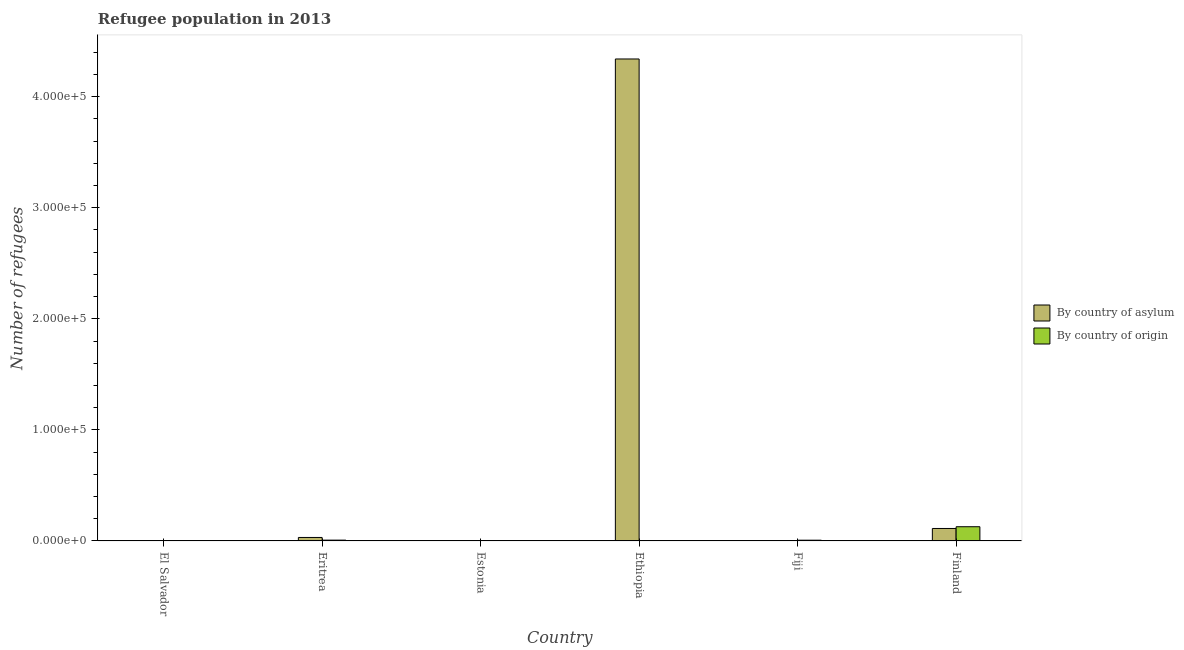How many groups of bars are there?
Provide a short and direct response. 6. Are the number of bars per tick equal to the number of legend labels?
Your answer should be compact. Yes. How many bars are there on the 3rd tick from the left?
Your response must be concise. 2. How many bars are there on the 5th tick from the right?
Your answer should be very brief. 2. What is the label of the 4th group of bars from the left?
Keep it short and to the point. Ethiopia. In how many cases, is the number of bars for a given country not equal to the number of legend labels?
Make the answer very short. 0. What is the number of refugees by country of asylum in Eritrea?
Offer a very short reply. 3166. Across all countries, what is the maximum number of refugees by country of origin?
Your answer should be very brief. 1.28e+04. Across all countries, what is the minimum number of refugees by country of asylum?
Provide a succinct answer. 5. In which country was the number of refugees by country of origin maximum?
Provide a short and direct response. Finland. In which country was the number of refugees by country of asylum minimum?
Ensure brevity in your answer.  Fiji. What is the total number of refugees by country of asylum in the graph?
Make the answer very short. 4.48e+05. What is the difference between the number of refugees by country of origin in Eritrea and that in Fiji?
Ensure brevity in your answer.  55. What is the difference between the number of refugees by country of asylum in El Salvador and the number of refugees by country of origin in Eritrea?
Provide a succinct answer. -718. What is the average number of refugees by country of origin per country?
Offer a very short reply. 2443.67. What is the difference between the number of refugees by country of asylum and number of refugees by country of origin in Fiji?
Offer a very short reply. -702. In how many countries, is the number of refugees by country of asylum greater than 260000 ?
Ensure brevity in your answer.  1. What is the ratio of the number of refugees by country of origin in El Salvador to that in Finland?
Your answer should be very brief. 0. What is the difference between the highest and the second highest number of refugees by country of origin?
Give a very brief answer. 1.21e+04. What is the difference between the highest and the lowest number of refugees by country of asylum?
Give a very brief answer. 4.34e+05. What does the 2nd bar from the left in Eritrea represents?
Your response must be concise. By country of origin. What does the 2nd bar from the right in Estonia represents?
Your answer should be very brief. By country of asylum. Are all the bars in the graph horizontal?
Keep it short and to the point. No. How many countries are there in the graph?
Provide a succinct answer. 6. What is the difference between two consecutive major ticks on the Y-axis?
Offer a terse response. 1.00e+05. Are the values on the major ticks of Y-axis written in scientific E-notation?
Your response must be concise. Yes. Does the graph contain any zero values?
Provide a short and direct response. No. Where does the legend appear in the graph?
Offer a terse response. Center right. How many legend labels are there?
Provide a succinct answer. 2. How are the legend labels stacked?
Offer a terse response. Vertical. What is the title of the graph?
Offer a very short reply. Refugee population in 2013. What is the label or title of the X-axis?
Provide a succinct answer. Country. What is the label or title of the Y-axis?
Keep it short and to the point. Number of refugees. What is the Number of refugees in By country of asylum in El Salvador?
Your response must be concise. 44. What is the Number of refugees of By country of asylum in Eritrea?
Provide a succinct answer. 3166. What is the Number of refugees of By country of origin in Eritrea?
Your response must be concise. 762. What is the Number of refugees of By country of asylum in Estonia?
Make the answer very short. 70. What is the Number of refugees of By country of asylum in Ethiopia?
Provide a short and direct response. 4.34e+05. What is the Number of refugees of By country of origin in Ethiopia?
Give a very brief answer. 306. What is the Number of refugees in By country of origin in Fiji?
Your answer should be very brief. 707. What is the Number of refugees in By country of asylum in Finland?
Your answer should be very brief. 1.13e+04. What is the Number of refugees in By country of origin in Finland?
Your answer should be compact. 1.28e+04. Across all countries, what is the maximum Number of refugees of By country of asylum?
Your response must be concise. 4.34e+05. Across all countries, what is the maximum Number of refugees in By country of origin?
Offer a terse response. 1.28e+04. Across all countries, what is the minimum Number of refugees in By country of asylum?
Provide a succinct answer. 5. Across all countries, what is the minimum Number of refugees in By country of origin?
Ensure brevity in your answer.  10. What is the total Number of refugees in By country of asylum in the graph?
Give a very brief answer. 4.48e+05. What is the total Number of refugees in By country of origin in the graph?
Give a very brief answer. 1.47e+04. What is the difference between the Number of refugees in By country of asylum in El Salvador and that in Eritrea?
Give a very brief answer. -3122. What is the difference between the Number of refugees of By country of origin in El Salvador and that in Eritrea?
Provide a succinct answer. -752. What is the difference between the Number of refugees in By country of asylum in El Salvador and that in Estonia?
Keep it short and to the point. -26. What is the difference between the Number of refugees in By country of origin in El Salvador and that in Estonia?
Offer a very short reply. -33. What is the difference between the Number of refugees of By country of asylum in El Salvador and that in Ethiopia?
Give a very brief answer. -4.34e+05. What is the difference between the Number of refugees in By country of origin in El Salvador and that in Ethiopia?
Provide a short and direct response. -296. What is the difference between the Number of refugees of By country of asylum in El Salvador and that in Fiji?
Offer a terse response. 39. What is the difference between the Number of refugees of By country of origin in El Salvador and that in Fiji?
Give a very brief answer. -697. What is the difference between the Number of refugees of By country of asylum in El Salvador and that in Finland?
Your response must be concise. -1.12e+04. What is the difference between the Number of refugees in By country of origin in El Salvador and that in Finland?
Make the answer very short. -1.28e+04. What is the difference between the Number of refugees in By country of asylum in Eritrea and that in Estonia?
Make the answer very short. 3096. What is the difference between the Number of refugees of By country of origin in Eritrea and that in Estonia?
Provide a short and direct response. 719. What is the difference between the Number of refugees in By country of asylum in Eritrea and that in Ethiopia?
Ensure brevity in your answer.  -4.31e+05. What is the difference between the Number of refugees of By country of origin in Eritrea and that in Ethiopia?
Keep it short and to the point. 456. What is the difference between the Number of refugees of By country of asylum in Eritrea and that in Fiji?
Keep it short and to the point. 3161. What is the difference between the Number of refugees in By country of origin in Eritrea and that in Fiji?
Ensure brevity in your answer.  55. What is the difference between the Number of refugees of By country of asylum in Eritrea and that in Finland?
Ensure brevity in your answer.  -8086. What is the difference between the Number of refugees of By country of origin in Eritrea and that in Finland?
Provide a succinct answer. -1.21e+04. What is the difference between the Number of refugees of By country of asylum in Estonia and that in Ethiopia?
Offer a terse response. -4.34e+05. What is the difference between the Number of refugees of By country of origin in Estonia and that in Ethiopia?
Offer a terse response. -263. What is the difference between the Number of refugees in By country of origin in Estonia and that in Fiji?
Your answer should be compact. -664. What is the difference between the Number of refugees of By country of asylum in Estonia and that in Finland?
Your response must be concise. -1.12e+04. What is the difference between the Number of refugees in By country of origin in Estonia and that in Finland?
Keep it short and to the point. -1.28e+04. What is the difference between the Number of refugees of By country of asylum in Ethiopia and that in Fiji?
Ensure brevity in your answer.  4.34e+05. What is the difference between the Number of refugees of By country of origin in Ethiopia and that in Fiji?
Offer a very short reply. -401. What is the difference between the Number of refugees of By country of asylum in Ethiopia and that in Finland?
Offer a very short reply. 4.23e+05. What is the difference between the Number of refugees of By country of origin in Ethiopia and that in Finland?
Your answer should be very brief. -1.25e+04. What is the difference between the Number of refugees of By country of asylum in Fiji and that in Finland?
Your answer should be very brief. -1.12e+04. What is the difference between the Number of refugees in By country of origin in Fiji and that in Finland?
Provide a short and direct response. -1.21e+04. What is the difference between the Number of refugees in By country of asylum in El Salvador and the Number of refugees in By country of origin in Eritrea?
Provide a short and direct response. -718. What is the difference between the Number of refugees in By country of asylum in El Salvador and the Number of refugees in By country of origin in Ethiopia?
Offer a very short reply. -262. What is the difference between the Number of refugees of By country of asylum in El Salvador and the Number of refugees of By country of origin in Fiji?
Offer a terse response. -663. What is the difference between the Number of refugees of By country of asylum in El Salvador and the Number of refugees of By country of origin in Finland?
Provide a succinct answer. -1.28e+04. What is the difference between the Number of refugees of By country of asylum in Eritrea and the Number of refugees of By country of origin in Estonia?
Give a very brief answer. 3123. What is the difference between the Number of refugees of By country of asylum in Eritrea and the Number of refugees of By country of origin in Ethiopia?
Keep it short and to the point. 2860. What is the difference between the Number of refugees in By country of asylum in Eritrea and the Number of refugees in By country of origin in Fiji?
Offer a terse response. 2459. What is the difference between the Number of refugees in By country of asylum in Eritrea and the Number of refugees in By country of origin in Finland?
Your answer should be compact. -9668. What is the difference between the Number of refugees of By country of asylum in Estonia and the Number of refugees of By country of origin in Ethiopia?
Your answer should be compact. -236. What is the difference between the Number of refugees in By country of asylum in Estonia and the Number of refugees in By country of origin in Fiji?
Provide a short and direct response. -637. What is the difference between the Number of refugees in By country of asylum in Estonia and the Number of refugees in By country of origin in Finland?
Provide a short and direct response. -1.28e+04. What is the difference between the Number of refugees of By country of asylum in Ethiopia and the Number of refugees of By country of origin in Fiji?
Provide a short and direct response. 4.33e+05. What is the difference between the Number of refugees in By country of asylum in Ethiopia and the Number of refugees in By country of origin in Finland?
Your response must be concise. 4.21e+05. What is the difference between the Number of refugees in By country of asylum in Fiji and the Number of refugees in By country of origin in Finland?
Provide a succinct answer. -1.28e+04. What is the average Number of refugees in By country of asylum per country?
Your answer should be compact. 7.47e+04. What is the average Number of refugees of By country of origin per country?
Give a very brief answer. 2443.67. What is the difference between the Number of refugees of By country of asylum and Number of refugees of By country of origin in Eritrea?
Offer a terse response. 2404. What is the difference between the Number of refugees in By country of asylum and Number of refugees in By country of origin in Estonia?
Your answer should be very brief. 27. What is the difference between the Number of refugees of By country of asylum and Number of refugees of By country of origin in Ethiopia?
Give a very brief answer. 4.34e+05. What is the difference between the Number of refugees in By country of asylum and Number of refugees in By country of origin in Fiji?
Make the answer very short. -702. What is the difference between the Number of refugees in By country of asylum and Number of refugees in By country of origin in Finland?
Ensure brevity in your answer.  -1582. What is the ratio of the Number of refugees of By country of asylum in El Salvador to that in Eritrea?
Ensure brevity in your answer.  0.01. What is the ratio of the Number of refugees in By country of origin in El Salvador to that in Eritrea?
Your answer should be compact. 0.01. What is the ratio of the Number of refugees of By country of asylum in El Salvador to that in Estonia?
Ensure brevity in your answer.  0.63. What is the ratio of the Number of refugees of By country of origin in El Salvador to that in Estonia?
Provide a succinct answer. 0.23. What is the ratio of the Number of refugees in By country of asylum in El Salvador to that in Ethiopia?
Your answer should be compact. 0. What is the ratio of the Number of refugees in By country of origin in El Salvador to that in Ethiopia?
Make the answer very short. 0.03. What is the ratio of the Number of refugees in By country of origin in El Salvador to that in Fiji?
Provide a succinct answer. 0.01. What is the ratio of the Number of refugees of By country of asylum in El Salvador to that in Finland?
Offer a terse response. 0. What is the ratio of the Number of refugees of By country of origin in El Salvador to that in Finland?
Make the answer very short. 0. What is the ratio of the Number of refugees of By country of asylum in Eritrea to that in Estonia?
Keep it short and to the point. 45.23. What is the ratio of the Number of refugees in By country of origin in Eritrea to that in Estonia?
Make the answer very short. 17.72. What is the ratio of the Number of refugees in By country of asylum in Eritrea to that in Ethiopia?
Offer a terse response. 0.01. What is the ratio of the Number of refugees in By country of origin in Eritrea to that in Ethiopia?
Make the answer very short. 2.49. What is the ratio of the Number of refugees in By country of asylum in Eritrea to that in Fiji?
Your answer should be compact. 633.2. What is the ratio of the Number of refugees of By country of origin in Eritrea to that in Fiji?
Keep it short and to the point. 1.08. What is the ratio of the Number of refugees in By country of asylum in Eritrea to that in Finland?
Offer a very short reply. 0.28. What is the ratio of the Number of refugees of By country of origin in Eritrea to that in Finland?
Provide a succinct answer. 0.06. What is the ratio of the Number of refugees of By country of asylum in Estonia to that in Ethiopia?
Offer a terse response. 0. What is the ratio of the Number of refugees in By country of origin in Estonia to that in Ethiopia?
Your answer should be very brief. 0.14. What is the ratio of the Number of refugees of By country of asylum in Estonia to that in Fiji?
Provide a short and direct response. 14. What is the ratio of the Number of refugees of By country of origin in Estonia to that in Fiji?
Keep it short and to the point. 0.06. What is the ratio of the Number of refugees in By country of asylum in Estonia to that in Finland?
Ensure brevity in your answer.  0.01. What is the ratio of the Number of refugees of By country of origin in Estonia to that in Finland?
Your answer should be compact. 0. What is the ratio of the Number of refugees of By country of asylum in Ethiopia to that in Fiji?
Offer a terse response. 8.68e+04. What is the ratio of the Number of refugees in By country of origin in Ethiopia to that in Fiji?
Provide a short and direct response. 0.43. What is the ratio of the Number of refugees in By country of asylum in Ethiopia to that in Finland?
Provide a short and direct response. 38.57. What is the ratio of the Number of refugees of By country of origin in Ethiopia to that in Finland?
Make the answer very short. 0.02. What is the ratio of the Number of refugees in By country of origin in Fiji to that in Finland?
Provide a succinct answer. 0.06. What is the difference between the highest and the second highest Number of refugees of By country of asylum?
Give a very brief answer. 4.23e+05. What is the difference between the highest and the second highest Number of refugees in By country of origin?
Your answer should be very brief. 1.21e+04. What is the difference between the highest and the lowest Number of refugees in By country of asylum?
Make the answer very short. 4.34e+05. What is the difference between the highest and the lowest Number of refugees in By country of origin?
Give a very brief answer. 1.28e+04. 